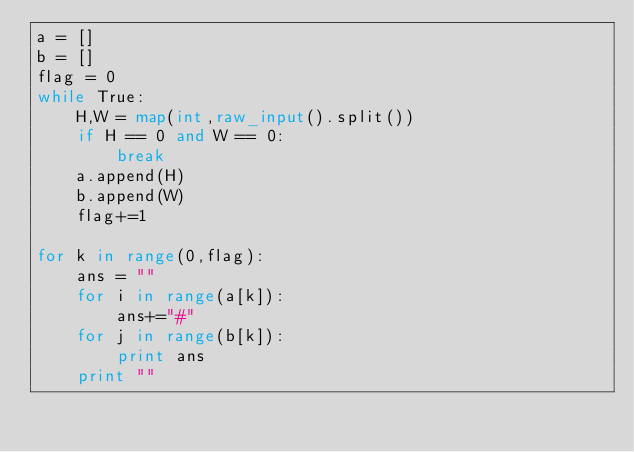Convert code to text. <code><loc_0><loc_0><loc_500><loc_500><_Python_>a = []
b = []
flag = 0
while True:
    H,W = map(int,raw_input().split())
    if H == 0 and W == 0:
        break
    a.append(H)
    b.append(W)
    flag+=1

for k in range(0,flag):
    ans = ""
    for i in range(a[k]):
        ans+="#"
    for j in range(b[k]):
        print ans
    print ""
</code> 